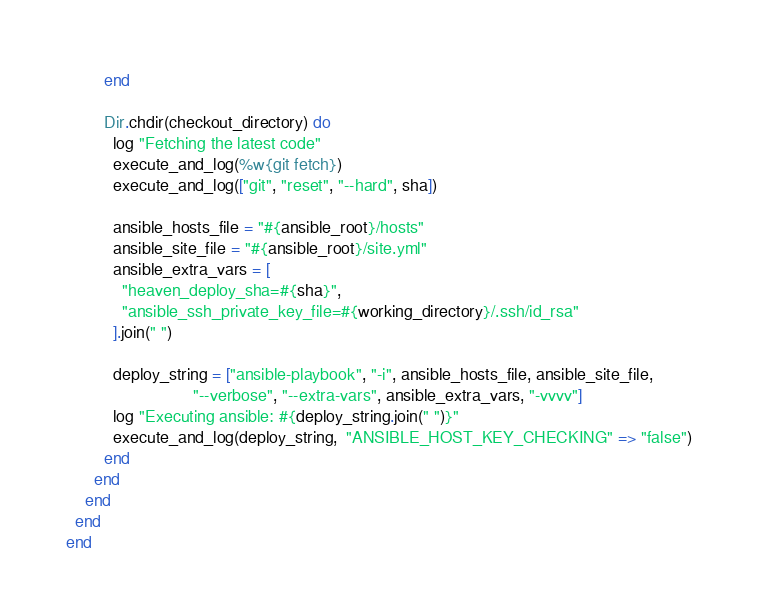<code> <loc_0><loc_0><loc_500><loc_500><_Ruby_>        end

        Dir.chdir(checkout_directory) do
          log "Fetching the latest code"
          execute_and_log(%w{git fetch})
          execute_and_log(["git", "reset", "--hard", sha])

          ansible_hosts_file = "#{ansible_root}/hosts"
          ansible_site_file = "#{ansible_root}/site.yml"
          ansible_extra_vars = [
            "heaven_deploy_sha=#{sha}",
            "ansible_ssh_private_key_file=#{working_directory}/.ssh/id_rsa"
          ].join(" ")

          deploy_string = ["ansible-playbook", "-i", ansible_hosts_file, ansible_site_file,
                           "--verbose", "--extra-vars", ansible_extra_vars, "-vvvv"]
          log "Executing ansible: #{deploy_string.join(" ")}"
          execute_and_log(deploy_string,  "ANSIBLE_HOST_KEY_CHECKING" => "false")
        end
      end
    end
  end
end
</code> 